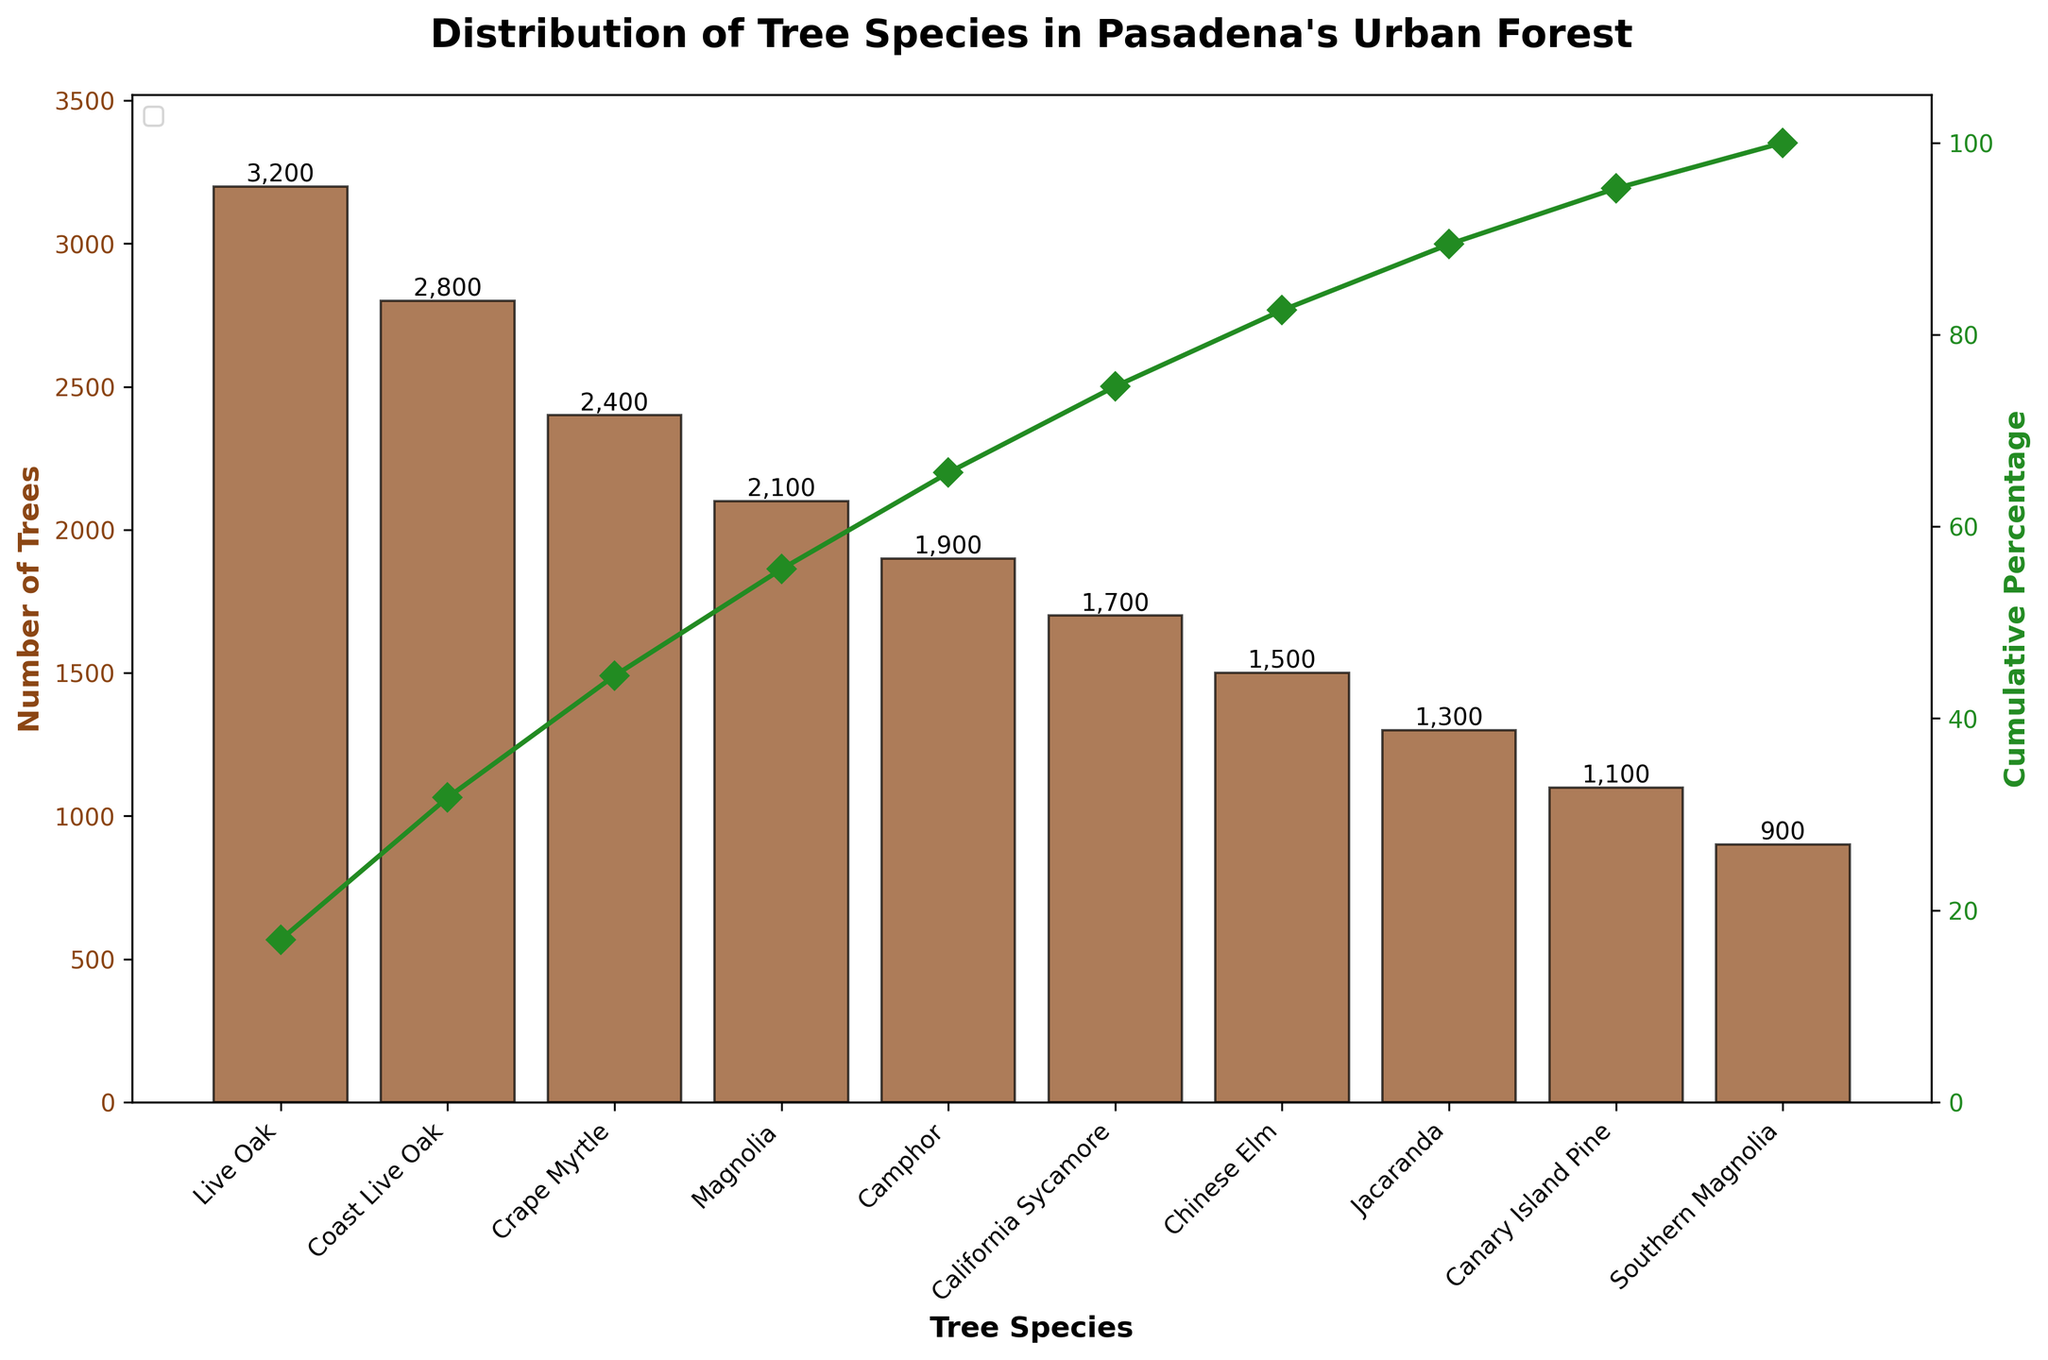What's the most common tree species in Pasadena's urban forest? Look at the bar chart and identify the tallest bar which represents the Live Oak species.
Answer: Live Oak What's the cumulative percentage of the three most common tree species? Add the cumulative percentages of the top three tree species (Live Oak, Coast Live Oak, and Crape Myrtle), which are approximately 18%, 34%, and 49%.
Answer: 49% Which two tree species have the least number of trees? Identify the shortest bars in the bar chart which represent the Canary Island Pine and Southern Magnolia species.
Answer: Canary Island Pine and Southern Magnolia What's the cumulative percentage after including the first five tree species? Sum the cumulative percentages shown by the line plot for the first five tree species (Live Oak, Coast Live Oak, Crape Myrtle, Magnolia, and Camphor). The values are approximately 18%, 34%, 49%, 61%, and 73%.
Answer: 73% Which tree species marks the point where the cumulative percentage first exceeds 50%? Identify where the line plot crosses the 50% mark; this occurs at Crape Myrtle.
Answer: Crape Myrtle How many tree species are listed in the dataset? Count the number of bars on the bar chart; there are ten bars representing ten species.
Answer: 10 By how many trees does the count of Live Oak exceed the count of Chinese Elm? Subtract the number of Chinese Elm trees from the number of Live Oak trees (3200 - 1500).
Answer: 1700 Which color represents the number of trees on the bar chart? Observe the color of the bars representing the number of trees, which is a brownish shade.
Answer: Brown What percentage of the total number of trees in Pasadena's urban forest is made up by the least common tree species? The least common species is Southern Magnolia with 900 trees. Calculate the percentage by dividing 900 by the total number of trees (17,400) and multiplying by 100. \(\frac{900}{17400} \times 100\)
Answer: Approximately 5.2% What's the difference in the number of trees between Magnolia and Camphor? Subtract the number of Camphor trees from the number of Magnolia trees (2100 - 1900).
Answer: 200 